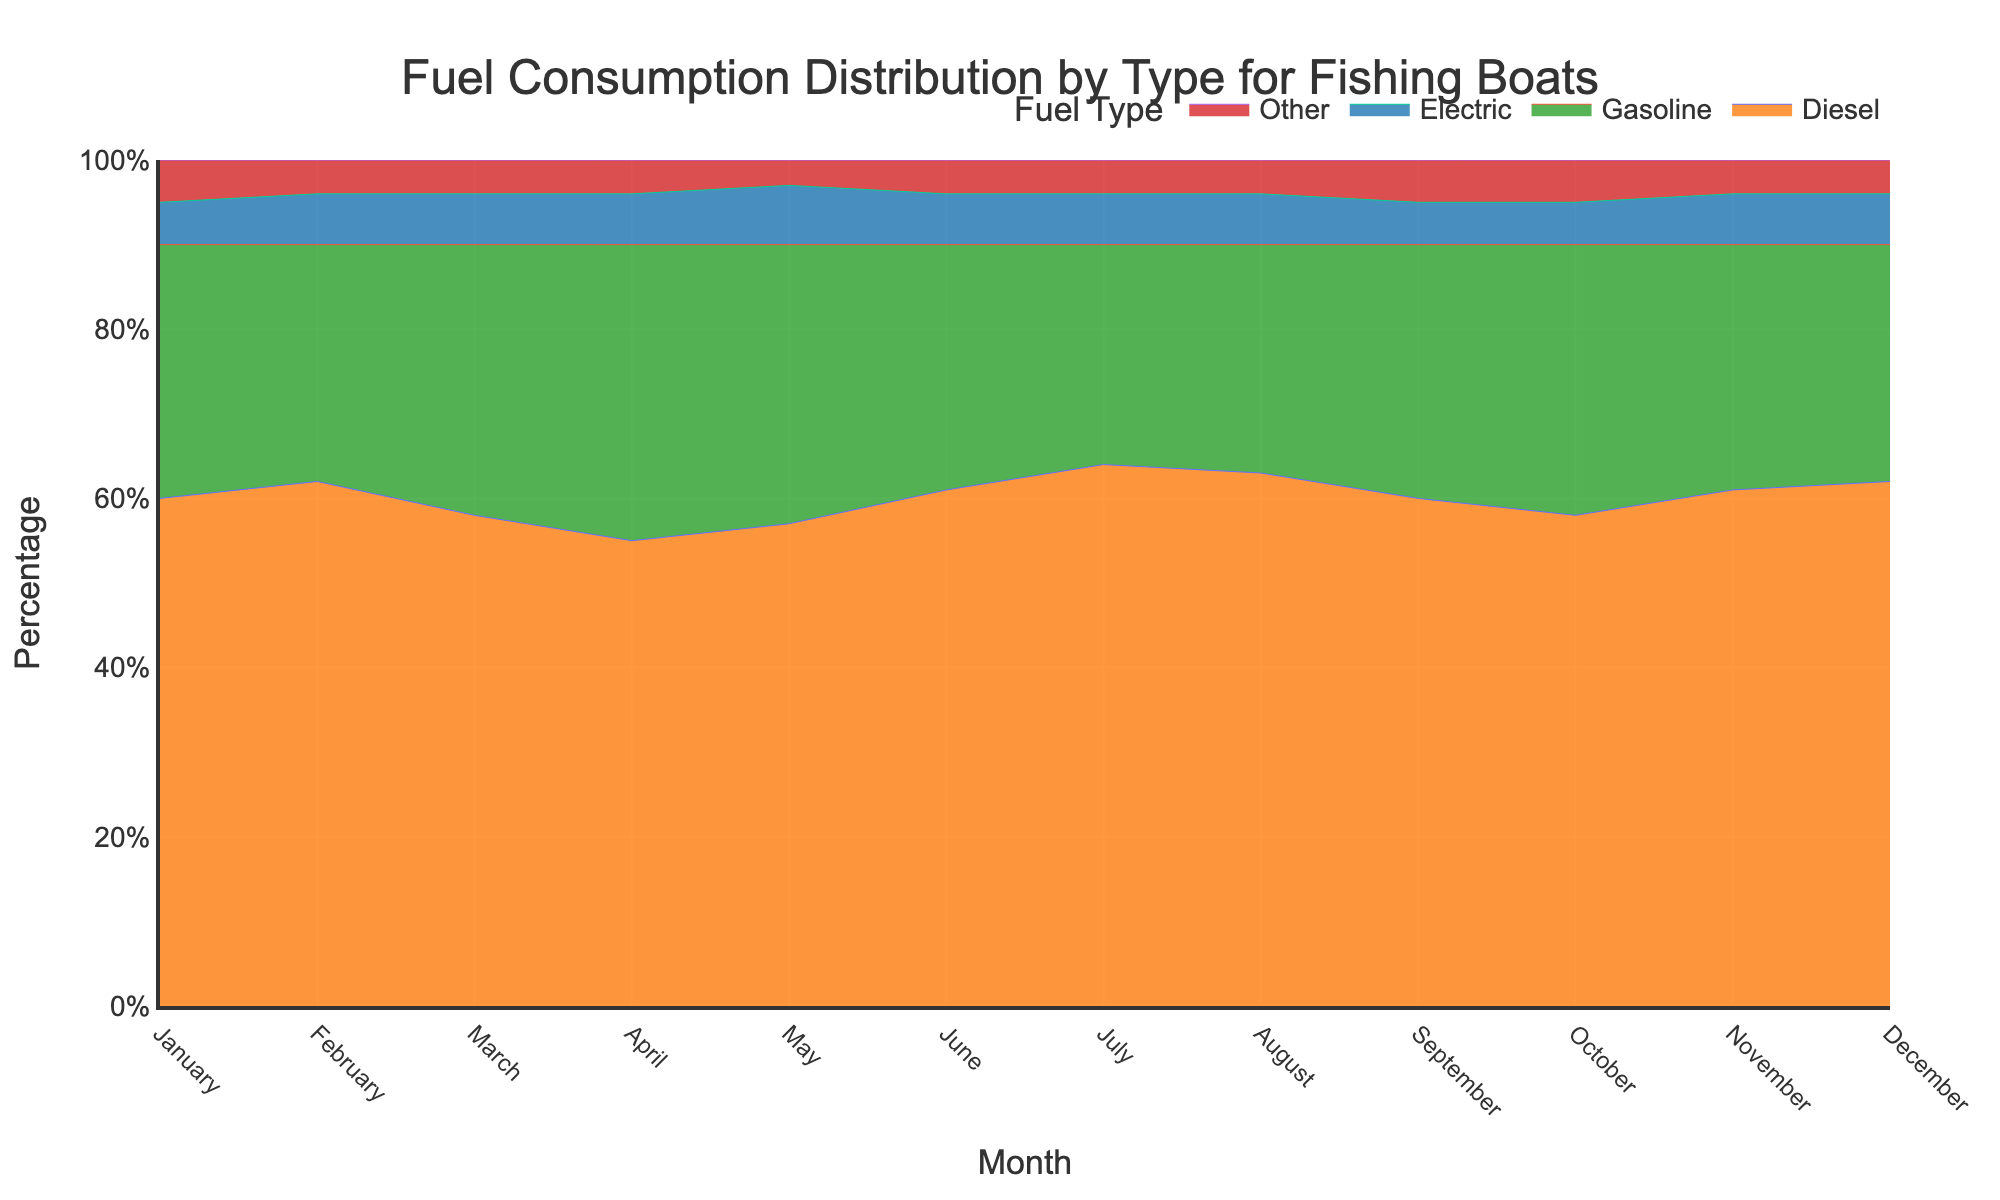Which month has the highest percentage for Diesel fuel consumption? By examining the stacked area chart, we can compare the height of the area corresponding to Diesel fuel for each month. Diesel has its highest coverage in July, where it occupies a larger portion of the vertical space compared to other months.
Answer: July What percentage of fuel consumption is Electric in May? In May, the Electric section in the stacked area chart is approximately 7% of the total fuel consumption.
Answer: 7% Which two months have the highest and lowest percentages for Gasoline fuel consumption? By analyzing the chart, we see that April has the highest percentage allocation for Gasoline fuel, while July has the lowest.
Answer: Highest: April, Lowest: July What is the overall trend for Diesel fuel consumption from January to December? Diesel fuel consumption shows a slightly fluctuating trend but starts at 60% in January, peaks at 64% in July, and ends at 62% in December.
Answer: Fluctuating with a peak in July How does the percentage of Other fuels in February compare to that in November? In the stacked area chart, both February and November show that the Other category occupies the same percentage of the area, which is 4%.
Answer: Equal in both months (4%) Compare the Electric fuel consumption in the first six months to the last six months. For the first six months, Electric consumption ranges from 5% to 7%. In the last six months, it stays at 5% or 6%. There is no significant difference between the two periods.
Answer: Similar in both periods In which month is the total fuel consumption of Diesel and Gasoline the highest? We need to add the percentages of Diesel and Gasoline for each month to find the month where their combined total is largest. April has Diesel at 55% and Gasoline at 35%, making the total 90%, which is the highest.
Answer: April What trend can you observe in the usage of Other fuels throughout the year? The Other fuels show a slight variability but mostly remain constant at around 4%-5% throughout the year.
Answer: Mostly constant at 4%-5% Which month shows the most balanced distribution across all fuel types? May shows a relatively balanced distribution with Diesel at 57%, Gasoline at 33%, Electric at 7%, and Other at 3%.
Answer: May What can you infer about the change in Diesel fuel consumption from March to April? The Diesel fuel percentage decreases from 58% in March to 55% in April, indicating a slight reduction.
Answer: Decreases 